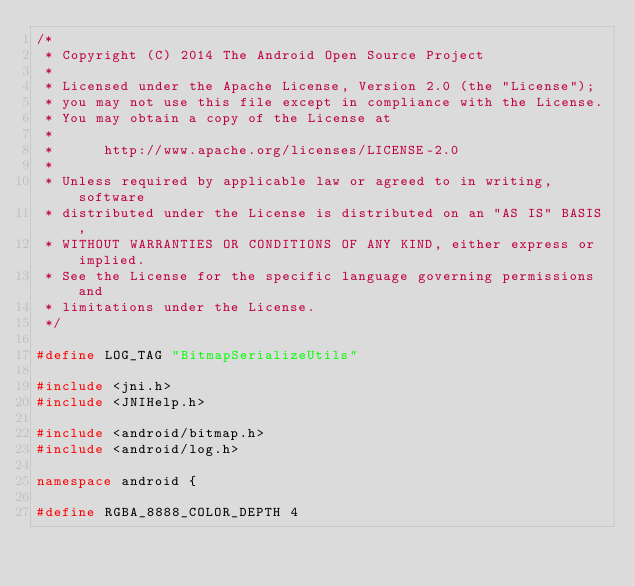Convert code to text. <code><loc_0><loc_0><loc_500><loc_500><_C++_>/*
 * Copyright (C) 2014 The Android Open Source Project
 *
 * Licensed under the Apache License, Version 2.0 (the "License");
 * you may not use this file except in compliance with the License.
 * You may obtain a copy of the License at
 *
 *      http://www.apache.org/licenses/LICENSE-2.0
 *
 * Unless required by applicable law or agreed to in writing, software
 * distributed under the License is distributed on an "AS IS" BASIS,
 * WITHOUT WARRANTIES OR CONDITIONS OF ANY KIND, either express or implied.
 * See the License for the specific language governing permissions and
 * limitations under the License.
 */

#define LOG_TAG "BitmapSerializeUtils"

#include <jni.h>
#include <JNIHelp.h>

#include <android/bitmap.h>
#include <android/log.h>

namespace android {

#define RGBA_8888_COLOR_DEPTH 4
</code> 